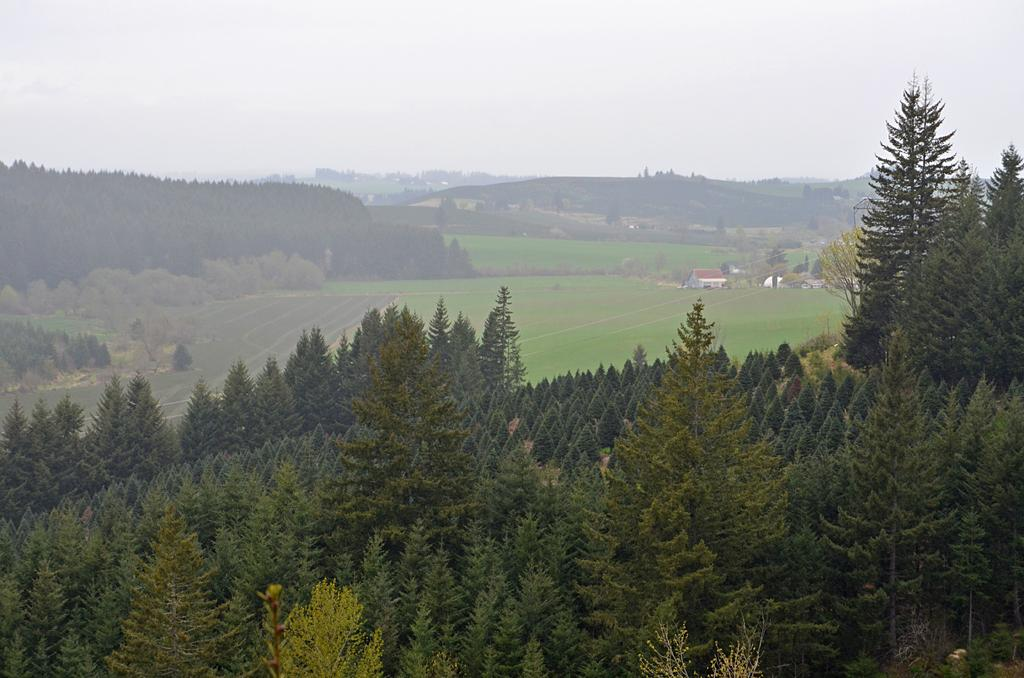What type of vegetation is present in the image? There are trees in the image. What structures can be seen in the background of the image? There are houses in the background of the image. What geographical features are visible in the background of the image? There are hills in the background of the image. What type of chalk is being used to draw on the hospital's walls in the image? There is no chalk or hospital present in the image; it features trees, houses, and hills in the background. 